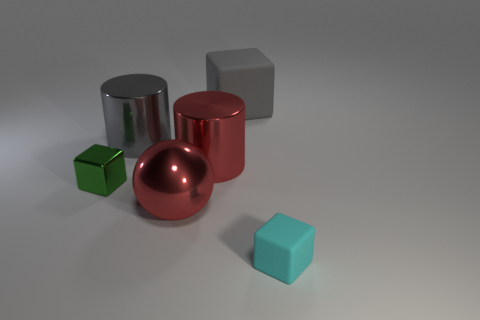Add 3 blue matte objects. How many objects exist? 9 Subtract all cylinders. How many objects are left? 4 Subtract all brown metallic blocks. Subtract all large red metal balls. How many objects are left? 5 Add 2 metallic cylinders. How many metallic cylinders are left? 4 Add 6 large cubes. How many large cubes exist? 7 Subtract 0 yellow blocks. How many objects are left? 6 